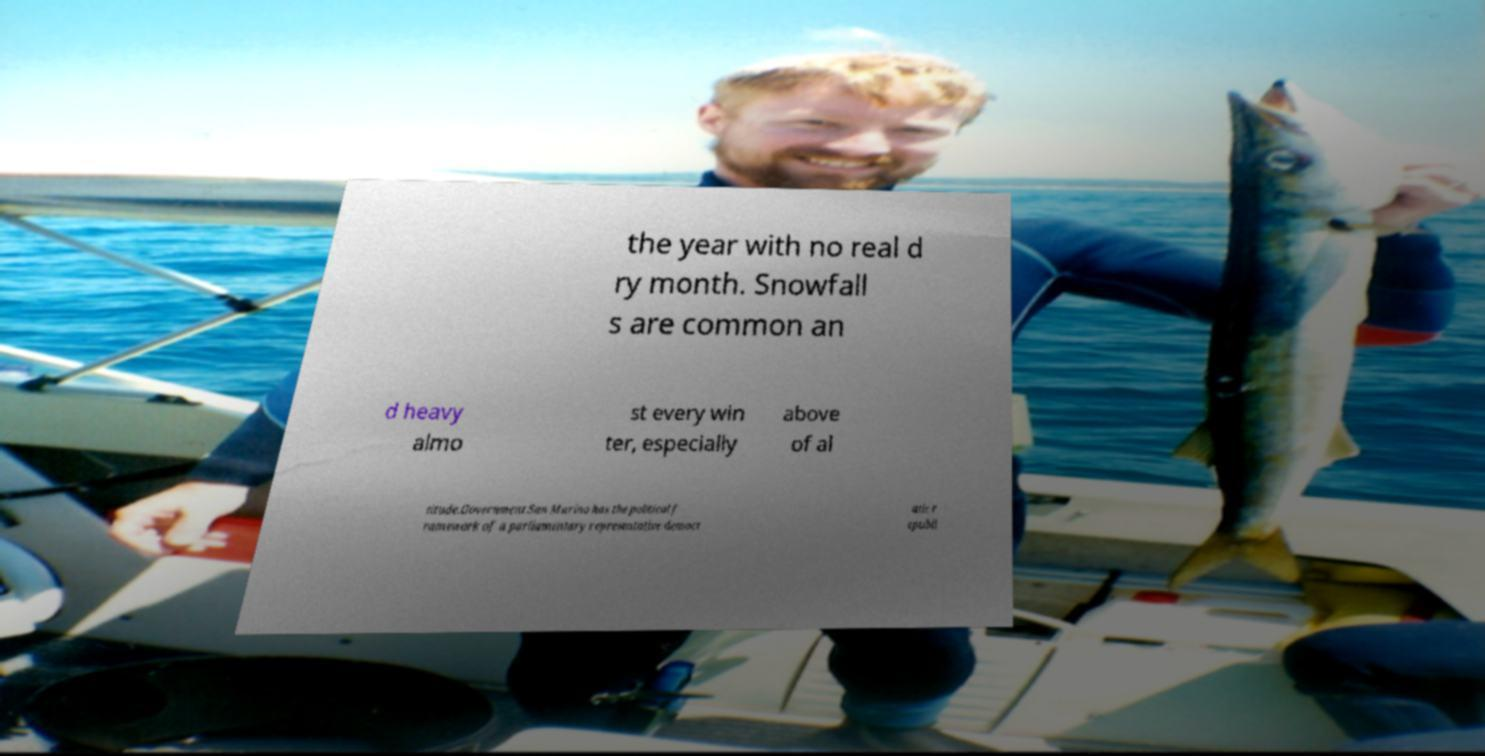Please read and relay the text visible in this image. What does it say? the year with no real d ry month. Snowfall s are common an d heavy almo st every win ter, especially above of al titude.Government.San Marino has the political f ramework of a parliamentary representative democr atic r epubli 